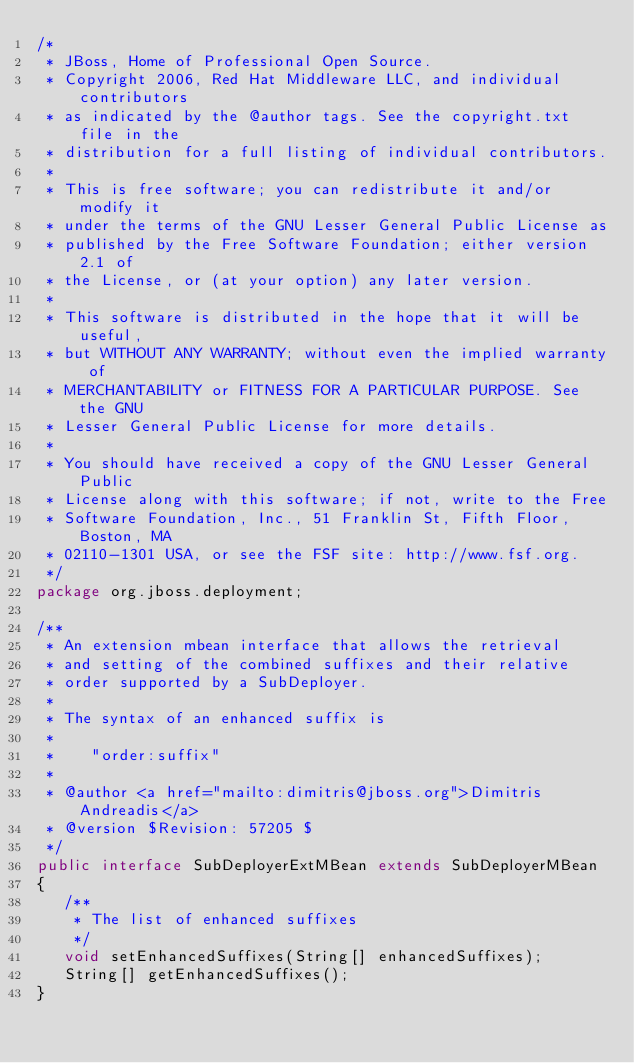Convert code to text. <code><loc_0><loc_0><loc_500><loc_500><_Java_>/*
 * JBoss, Home of Professional Open Source.
 * Copyright 2006, Red Hat Middleware LLC, and individual contributors
 * as indicated by the @author tags. See the copyright.txt file in the
 * distribution for a full listing of individual contributors.
 *
 * This is free software; you can redistribute it and/or modify it
 * under the terms of the GNU Lesser General Public License as
 * published by the Free Software Foundation; either version 2.1 of
 * the License, or (at your option) any later version.
 *
 * This software is distributed in the hope that it will be useful,
 * but WITHOUT ANY WARRANTY; without even the implied warranty of
 * MERCHANTABILITY or FITNESS FOR A PARTICULAR PURPOSE. See the GNU
 * Lesser General Public License for more details.
 *
 * You should have received a copy of the GNU Lesser General Public
 * License along with this software; if not, write to the Free
 * Software Foundation, Inc., 51 Franklin St, Fifth Floor, Boston, MA
 * 02110-1301 USA, or see the FSF site: http://www.fsf.org.
 */
package org.jboss.deployment;

/**
 * An extension mbean interface that allows the retrieval
 * and setting of the combined suffixes and their relative
 * order supported by a SubDeployer.
 * 
 * The syntax of an enhanced suffix is
 * 
 *    "order:suffix"
 * 
 * @author <a href="mailto:dimitris@jboss.org">Dimitris Andreadis</a>
 * @version $Revision: 57205 $
 */
public interface SubDeployerExtMBean extends SubDeployerMBean
{
   /**
    * The list of enhanced suffixes
    */
   void setEnhancedSuffixes(String[] enhancedSuffixes);
   String[] getEnhancedSuffixes();
}
</code> 